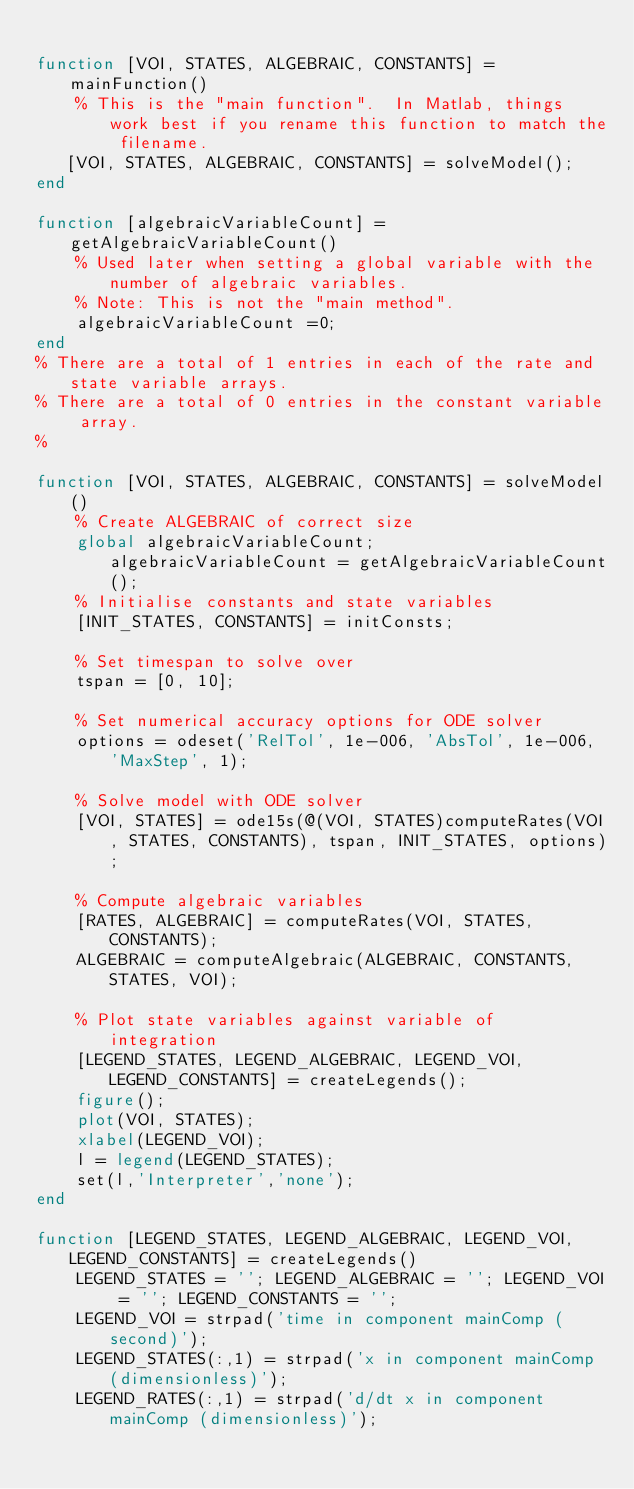Convert code to text. <code><loc_0><loc_0><loc_500><loc_500><_Matlab_>
function [VOI, STATES, ALGEBRAIC, CONSTANTS] = mainFunction()
    % This is the "main function".  In Matlab, things work best if you rename this function to match the filename.
   [VOI, STATES, ALGEBRAIC, CONSTANTS] = solveModel();
end

function [algebraicVariableCount] = getAlgebraicVariableCount()
    % Used later when setting a global variable with the number of algebraic variables.
    % Note: This is not the "main method".
    algebraicVariableCount =0;
end
% There are a total of 1 entries in each of the rate and state variable arrays.
% There are a total of 0 entries in the constant variable array.
%

function [VOI, STATES, ALGEBRAIC, CONSTANTS] = solveModel()
    % Create ALGEBRAIC of correct size
    global algebraicVariableCount;  algebraicVariableCount = getAlgebraicVariableCount();
    % Initialise constants and state variables
    [INIT_STATES, CONSTANTS] = initConsts;

    % Set timespan to solve over
    tspan = [0, 10];

    % Set numerical accuracy options for ODE solver
    options = odeset('RelTol', 1e-006, 'AbsTol', 1e-006, 'MaxStep', 1);

    % Solve model with ODE solver
    [VOI, STATES] = ode15s(@(VOI, STATES)computeRates(VOI, STATES, CONSTANTS), tspan, INIT_STATES, options);

    % Compute algebraic variables
    [RATES, ALGEBRAIC] = computeRates(VOI, STATES, CONSTANTS);
    ALGEBRAIC = computeAlgebraic(ALGEBRAIC, CONSTANTS, STATES, VOI);

    % Plot state variables against variable of integration
    [LEGEND_STATES, LEGEND_ALGEBRAIC, LEGEND_VOI, LEGEND_CONSTANTS] = createLegends();
    figure();
    plot(VOI, STATES);
    xlabel(LEGEND_VOI);
    l = legend(LEGEND_STATES);
    set(l,'Interpreter','none');
end

function [LEGEND_STATES, LEGEND_ALGEBRAIC, LEGEND_VOI, LEGEND_CONSTANTS] = createLegends()
    LEGEND_STATES = ''; LEGEND_ALGEBRAIC = ''; LEGEND_VOI = ''; LEGEND_CONSTANTS = '';
    LEGEND_VOI = strpad('time in component mainComp (second)');
    LEGEND_STATES(:,1) = strpad('x in component mainComp (dimensionless)');
    LEGEND_RATES(:,1) = strpad('d/dt x in component mainComp (dimensionless)');</code> 